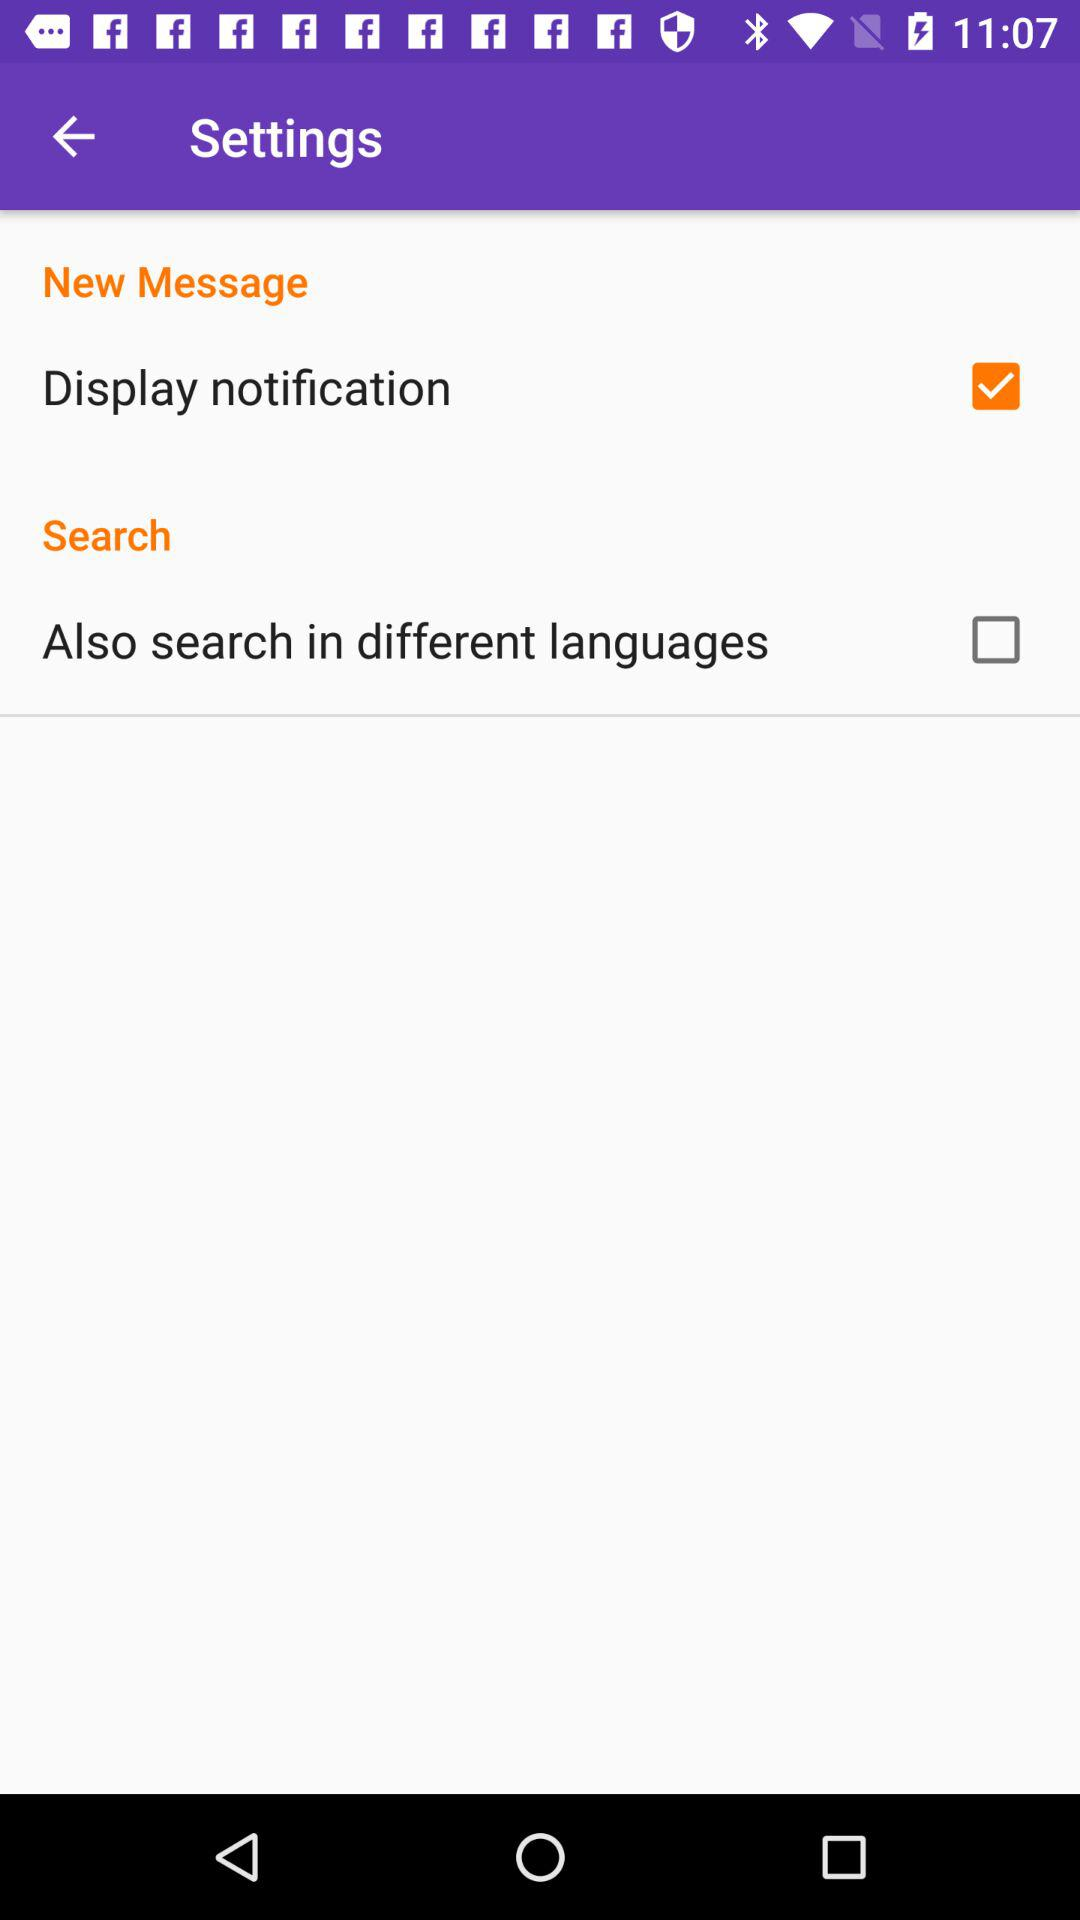What is the current status of the "Also search in different languages"? The status is "off". 